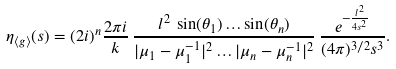Convert formula to latex. <formula><loc_0><loc_0><loc_500><loc_500>\eta _ { \langle g \rangle } ( s ) = ( 2 i ) ^ { n } \frac { 2 \pi i } { k } \, \frac { l ^ { 2 } \, \sin ( \theta _ { 1 } ) \dots \sin ( \theta _ { n } ) } { | \mu _ { 1 } - \mu _ { 1 } ^ { - 1 } | ^ { 2 } \dots | \mu _ { n } - \mu _ { n } ^ { - 1 } | ^ { 2 } } \, \frac { e ^ { - \frac { l ^ { 2 } } { 4 s ^ { 2 } } } } { ( 4 \pi ) ^ { 3 / 2 } s ^ { 3 } } .</formula> 